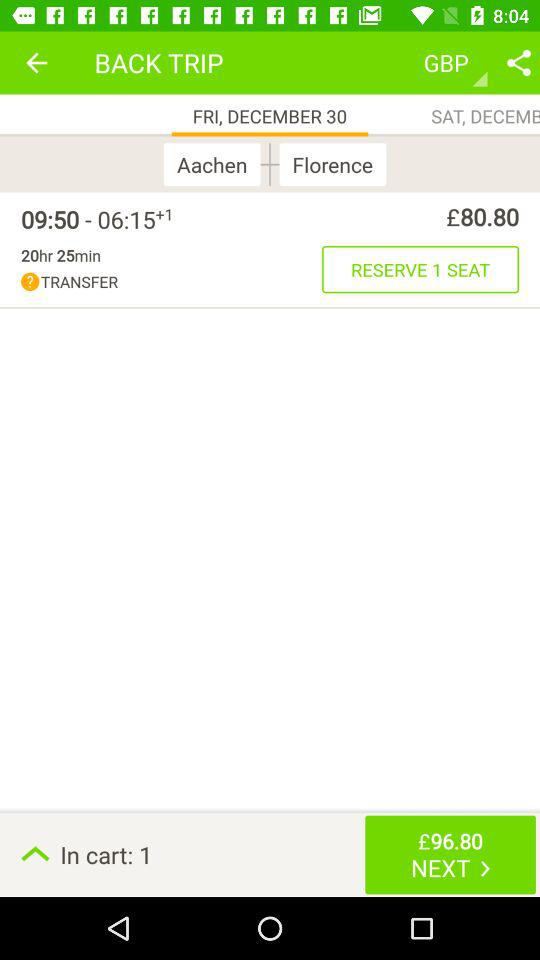What day is December 30th? The day is Friday. 